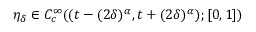Convert formula to latex. <formula><loc_0><loc_0><loc_500><loc_500>\eta _ { \delta } \in C _ { c } ^ { \infty } ( ( t - ( 2 \delta ) ^ { \alpha } , t + ( 2 \delta ) ^ { \alpha } ) ; [ 0 , 1 ] )</formula> 